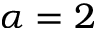<formula> <loc_0><loc_0><loc_500><loc_500>\alpha = 2</formula> 